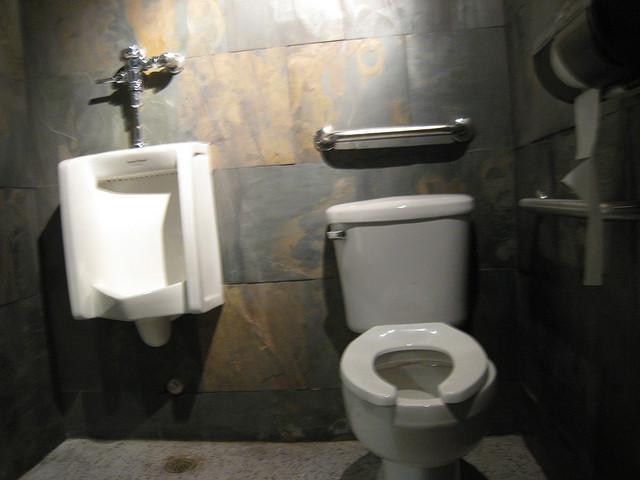How many toilets are there?
Give a very brief answer. 2. 